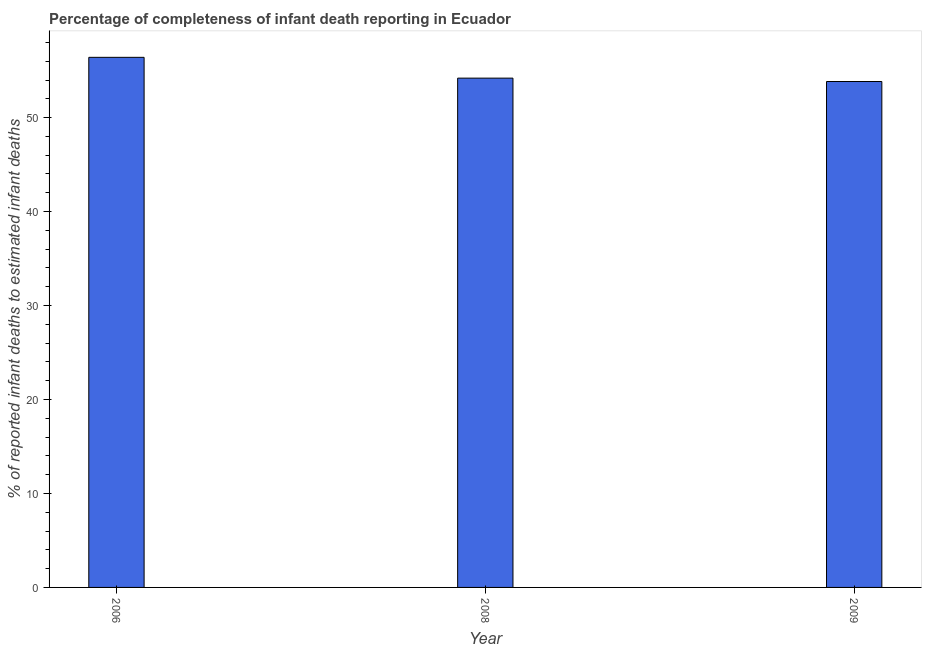Does the graph contain grids?
Your response must be concise. No. What is the title of the graph?
Offer a terse response. Percentage of completeness of infant death reporting in Ecuador. What is the label or title of the X-axis?
Your answer should be compact. Year. What is the label or title of the Y-axis?
Your answer should be compact. % of reported infant deaths to estimated infant deaths. What is the completeness of infant death reporting in 2006?
Provide a succinct answer. 56.42. Across all years, what is the maximum completeness of infant death reporting?
Provide a short and direct response. 56.42. Across all years, what is the minimum completeness of infant death reporting?
Make the answer very short. 53.84. What is the sum of the completeness of infant death reporting?
Offer a very short reply. 164.46. What is the difference between the completeness of infant death reporting in 2008 and 2009?
Ensure brevity in your answer.  0.36. What is the average completeness of infant death reporting per year?
Offer a terse response. 54.82. What is the median completeness of infant death reporting?
Offer a very short reply. 54.2. In how many years, is the completeness of infant death reporting greater than 16 %?
Keep it short and to the point. 3. What is the ratio of the completeness of infant death reporting in 2006 to that in 2008?
Make the answer very short. 1.04. Is the completeness of infant death reporting in 2008 less than that in 2009?
Provide a short and direct response. No. What is the difference between the highest and the second highest completeness of infant death reporting?
Offer a very short reply. 2.21. Is the sum of the completeness of infant death reporting in 2006 and 2008 greater than the maximum completeness of infant death reporting across all years?
Your answer should be compact. Yes. What is the difference between the highest and the lowest completeness of infant death reporting?
Your response must be concise. 2.57. How many bars are there?
Offer a terse response. 3. Are all the bars in the graph horizontal?
Provide a short and direct response. No. What is the difference between two consecutive major ticks on the Y-axis?
Your response must be concise. 10. What is the % of reported infant deaths to estimated infant deaths of 2006?
Make the answer very short. 56.42. What is the % of reported infant deaths to estimated infant deaths of 2008?
Ensure brevity in your answer.  54.2. What is the % of reported infant deaths to estimated infant deaths in 2009?
Offer a very short reply. 53.84. What is the difference between the % of reported infant deaths to estimated infant deaths in 2006 and 2008?
Give a very brief answer. 2.21. What is the difference between the % of reported infant deaths to estimated infant deaths in 2006 and 2009?
Your response must be concise. 2.57. What is the difference between the % of reported infant deaths to estimated infant deaths in 2008 and 2009?
Ensure brevity in your answer.  0.36. What is the ratio of the % of reported infant deaths to estimated infant deaths in 2006 to that in 2008?
Offer a very short reply. 1.04. What is the ratio of the % of reported infant deaths to estimated infant deaths in 2006 to that in 2009?
Make the answer very short. 1.05. 